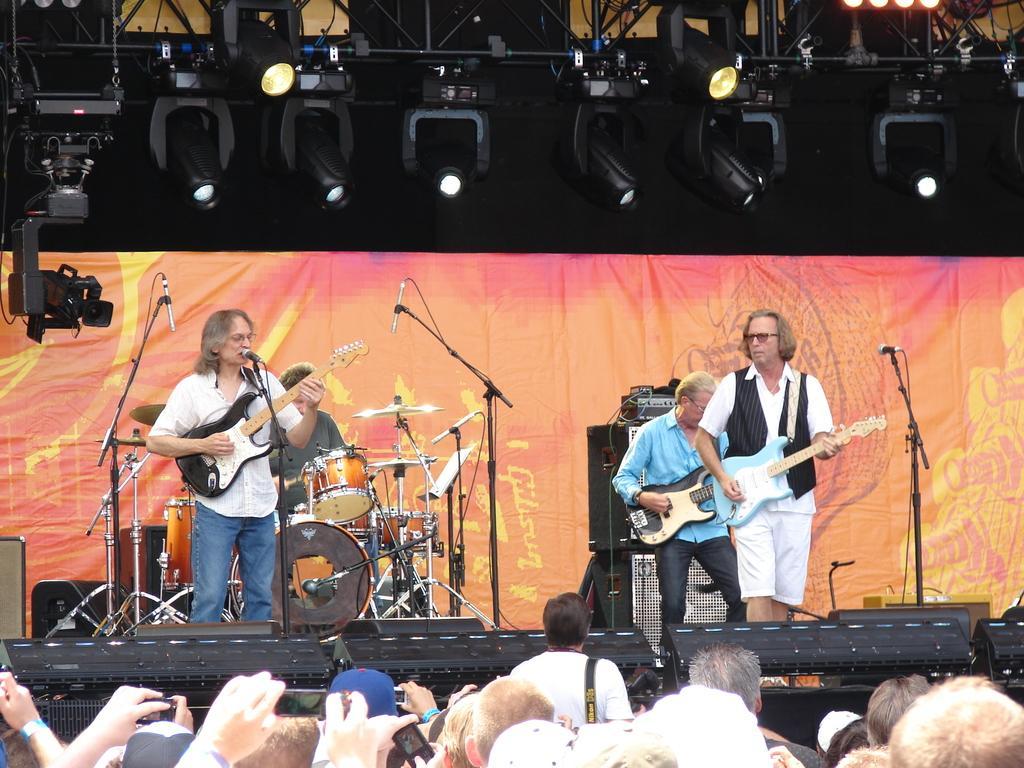In one or two sentences, can you explain what this image depicts? In this picture there are people standing on the days, we can see a person singing and playing the guitar on the right people are playing guitar and in the ground the person who is playing the drum set does a camera over here and there are some ceiling lights attached there is full crowd in front of them and in the Background Eraser screen 